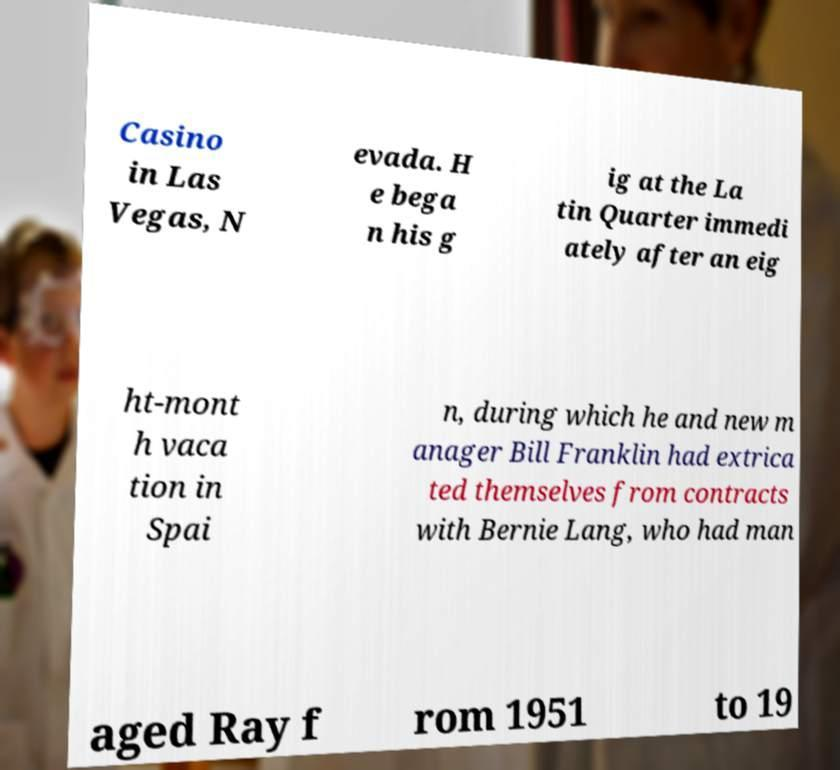Could you assist in decoding the text presented in this image and type it out clearly? Casino in Las Vegas, N evada. H e bega n his g ig at the La tin Quarter immedi ately after an eig ht-mont h vaca tion in Spai n, during which he and new m anager Bill Franklin had extrica ted themselves from contracts with Bernie Lang, who had man aged Ray f rom 1951 to 19 